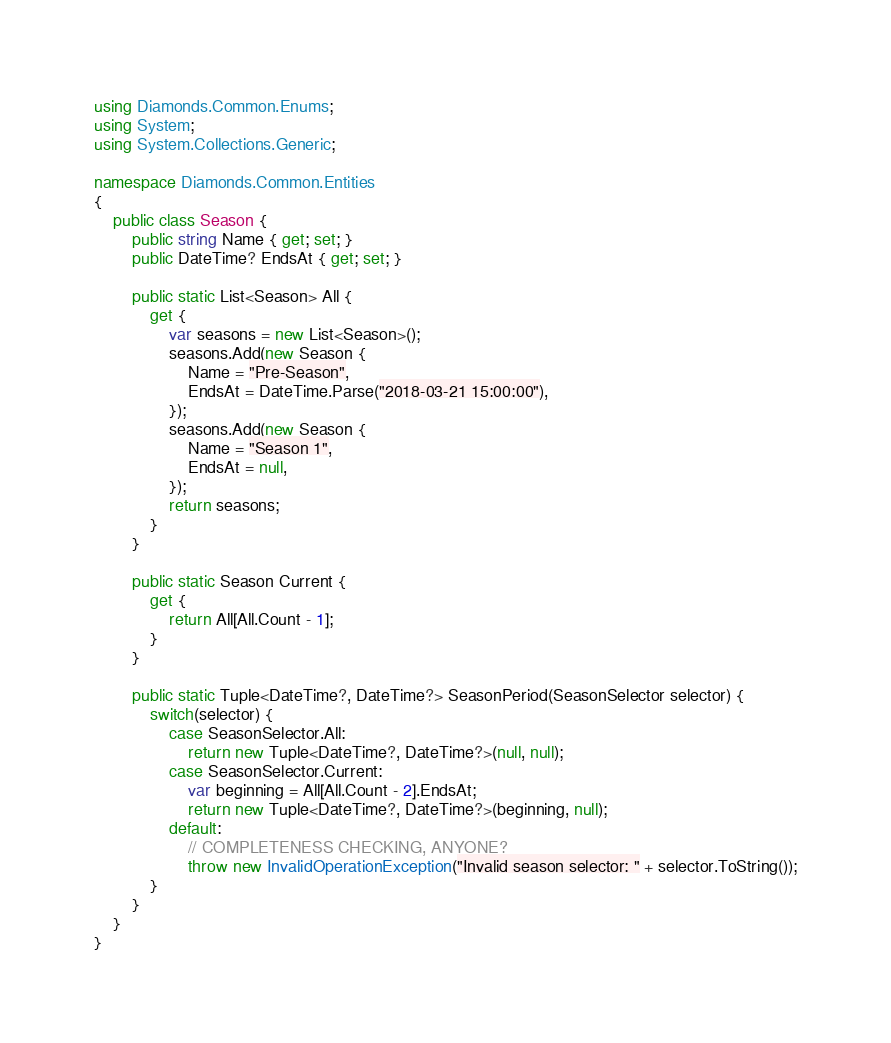Convert code to text. <code><loc_0><loc_0><loc_500><loc_500><_C#_>using Diamonds.Common.Enums;
using System;
using System.Collections.Generic;

namespace Diamonds.Common.Entities
{
    public class Season {
        public string Name { get; set; }
        public DateTime? EndsAt { get; set; }

        public static List<Season> All {
            get {
                var seasons = new List<Season>();
                seasons.Add(new Season {
                    Name = "Pre-Season",
                    EndsAt = DateTime.Parse("2018-03-21 15:00:00"),
                });
                seasons.Add(new Season {
                    Name = "Season 1",
                    EndsAt = null,
                });
                return seasons;
            }
        }

        public static Season Current {
            get {
                return All[All.Count - 1];
            }
        }

        public static Tuple<DateTime?, DateTime?> SeasonPeriod(SeasonSelector selector) {
            switch(selector) {
                case SeasonSelector.All:
                    return new Tuple<DateTime?, DateTime?>(null, null);
                case SeasonSelector.Current:
                    var beginning = All[All.Count - 2].EndsAt;
                    return new Tuple<DateTime?, DateTime?>(beginning, null);
                default:
                    // COMPLETENESS CHECKING, ANYONE?
                    throw new InvalidOperationException("Invalid season selector: " + selector.ToString());
            }
        }
    }
}
</code> 